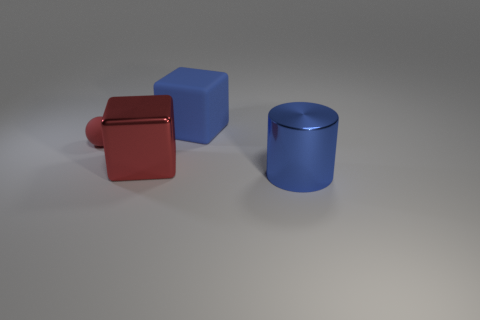What material is the large cube to the right of the large metal thing that is to the left of the blue thing right of the large matte thing?
Offer a very short reply. Rubber. What number of other things are the same size as the red matte thing?
Make the answer very short. 0. Is the ball the same color as the rubber cube?
Give a very brief answer. No. There is a metallic thing that is behind the metal thing to the right of the large blue block; how many big cylinders are behind it?
Offer a terse response. 0. What is the material of the thing that is to the right of the large rubber cube that is to the left of the blue shiny thing?
Give a very brief answer. Metal. Are there any other matte things of the same shape as the small thing?
Give a very brief answer. No. What color is the other metal object that is the same size as the red metallic thing?
Provide a succinct answer. Blue. What number of objects are blue things to the left of the big blue metal cylinder or big blue things on the left side of the blue shiny thing?
Offer a terse response. 1. What number of things are either blue matte things or blue cylinders?
Provide a short and direct response. 2. There is a thing that is behind the big red metal object and on the left side of the blue block; how big is it?
Offer a very short reply. Small. 